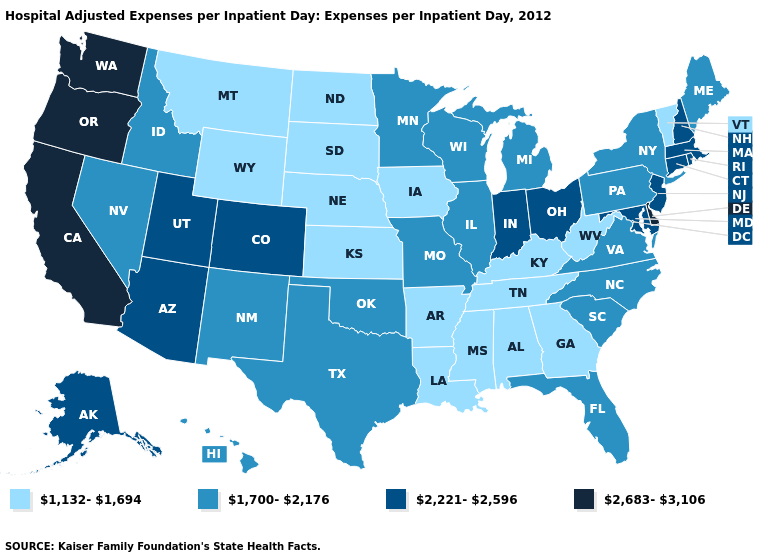Does Maine have a lower value than New Jersey?
Concise answer only. Yes. Does the first symbol in the legend represent the smallest category?
Keep it brief. Yes. Which states hav the highest value in the South?
Keep it brief. Delaware. What is the value of Kansas?
Answer briefly. 1,132-1,694. What is the highest value in the South ?
Be succinct. 2,683-3,106. Does Delaware have the highest value in the South?
Quick response, please. Yes. Does Oregon have the same value as Hawaii?
Keep it brief. No. What is the lowest value in states that border Illinois?
Write a very short answer. 1,132-1,694. Which states have the lowest value in the South?
Answer briefly. Alabama, Arkansas, Georgia, Kentucky, Louisiana, Mississippi, Tennessee, West Virginia. What is the highest value in the MidWest ?
Be succinct. 2,221-2,596. Does Wyoming have the same value as Alaska?
Keep it brief. No. Does New Jersey have the lowest value in the Northeast?
Be succinct. No. Name the states that have a value in the range 1,700-2,176?
Quick response, please. Florida, Hawaii, Idaho, Illinois, Maine, Michigan, Minnesota, Missouri, Nevada, New Mexico, New York, North Carolina, Oklahoma, Pennsylvania, South Carolina, Texas, Virginia, Wisconsin. Among the states that border Colorado , does Arizona have the highest value?
Write a very short answer. Yes. Name the states that have a value in the range 1,700-2,176?
Short answer required. Florida, Hawaii, Idaho, Illinois, Maine, Michigan, Minnesota, Missouri, Nevada, New Mexico, New York, North Carolina, Oklahoma, Pennsylvania, South Carolina, Texas, Virginia, Wisconsin. 